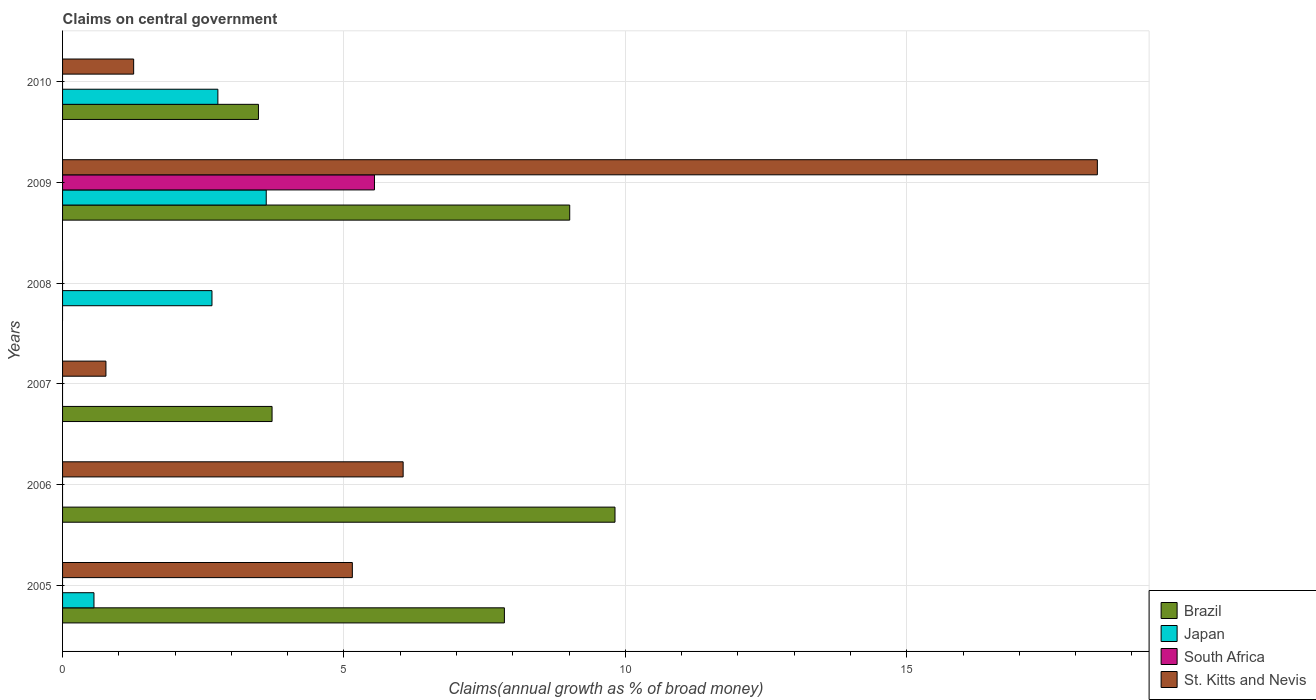How many different coloured bars are there?
Provide a short and direct response. 4. Are the number of bars on each tick of the Y-axis equal?
Your answer should be compact. No. What is the label of the 3rd group of bars from the top?
Make the answer very short. 2008. In how many cases, is the number of bars for a given year not equal to the number of legend labels?
Keep it short and to the point. 5. What is the percentage of broad money claimed on centeral government in Brazil in 2010?
Give a very brief answer. 3.48. Across all years, what is the maximum percentage of broad money claimed on centeral government in St. Kitts and Nevis?
Your response must be concise. 18.39. What is the total percentage of broad money claimed on centeral government in Japan in the graph?
Provide a short and direct response. 9.59. What is the difference between the percentage of broad money claimed on centeral government in St. Kitts and Nevis in 2006 and that in 2010?
Make the answer very short. 4.79. What is the difference between the percentage of broad money claimed on centeral government in St. Kitts and Nevis in 2006 and the percentage of broad money claimed on centeral government in Japan in 2008?
Your answer should be very brief. 3.4. What is the average percentage of broad money claimed on centeral government in South Africa per year?
Your answer should be compact. 0.92. In the year 2006, what is the difference between the percentage of broad money claimed on centeral government in St. Kitts and Nevis and percentage of broad money claimed on centeral government in Brazil?
Provide a short and direct response. -3.76. Is the percentage of broad money claimed on centeral government in St. Kitts and Nevis in 2007 less than that in 2009?
Make the answer very short. Yes. Is the difference between the percentage of broad money claimed on centeral government in St. Kitts and Nevis in 2005 and 2010 greater than the difference between the percentage of broad money claimed on centeral government in Brazil in 2005 and 2010?
Your answer should be compact. No. What is the difference between the highest and the second highest percentage of broad money claimed on centeral government in St. Kitts and Nevis?
Make the answer very short. 12.33. What is the difference between the highest and the lowest percentage of broad money claimed on centeral government in St. Kitts and Nevis?
Provide a succinct answer. 18.39. Is it the case that in every year, the sum of the percentage of broad money claimed on centeral government in Japan and percentage of broad money claimed on centeral government in St. Kitts and Nevis is greater than the percentage of broad money claimed on centeral government in Brazil?
Make the answer very short. No. How many bars are there?
Your answer should be compact. 15. How many years are there in the graph?
Your response must be concise. 6. What is the difference between two consecutive major ticks on the X-axis?
Provide a succinct answer. 5. Are the values on the major ticks of X-axis written in scientific E-notation?
Give a very brief answer. No. Does the graph contain any zero values?
Ensure brevity in your answer.  Yes. Where does the legend appear in the graph?
Provide a succinct answer. Bottom right. How many legend labels are there?
Provide a short and direct response. 4. How are the legend labels stacked?
Your answer should be compact. Vertical. What is the title of the graph?
Your answer should be very brief. Claims on central government. What is the label or title of the X-axis?
Make the answer very short. Claims(annual growth as % of broad money). What is the label or title of the Y-axis?
Offer a very short reply. Years. What is the Claims(annual growth as % of broad money) in Brazil in 2005?
Make the answer very short. 7.85. What is the Claims(annual growth as % of broad money) in Japan in 2005?
Your answer should be very brief. 0.56. What is the Claims(annual growth as % of broad money) of St. Kitts and Nevis in 2005?
Provide a short and direct response. 5.15. What is the Claims(annual growth as % of broad money) in Brazil in 2006?
Your answer should be compact. 9.82. What is the Claims(annual growth as % of broad money) of South Africa in 2006?
Offer a terse response. 0. What is the Claims(annual growth as % of broad money) of St. Kitts and Nevis in 2006?
Give a very brief answer. 6.05. What is the Claims(annual growth as % of broad money) of Brazil in 2007?
Make the answer very short. 3.72. What is the Claims(annual growth as % of broad money) of Japan in 2007?
Keep it short and to the point. 0. What is the Claims(annual growth as % of broad money) of St. Kitts and Nevis in 2007?
Your answer should be compact. 0.77. What is the Claims(annual growth as % of broad money) in Japan in 2008?
Your response must be concise. 2.65. What is the Claims(annual growth as % of broad money) in South Africa in 2008?
Your response must be concise. 0. What is the Claims(annual growth as % of broad money) of St. Kitts and Nevis in 2008?
Make the answer very short. 0. What is the Claims(annual growth as % of broad money) of Brazil in 2009?
Provide a short and direct response. 9.01. What is the Claims(annual growth as % of broad money) in Japan in 2009?
Your answer should be compact. 3.62. What is the Claims(annual growth as % of broad money) in South Africa in 2009?
Your response must be concise. 5.54. What is the Claims(annual growth as % of broad money) of St. Kitts and Nevis in 2009?
Your response must be concise. 18.39. What is the Claims(annual growth as % of broad money) in Brazil in 2010?
Provide a succinct answer. 3.48. What is the Claims(annual growth as % of broad money) of Japan in 2010?
Your response must be concise. 2.76. What is the Claims(annual growth as % of broad money) in South Africa in 2010?
Provide a succinct answer. 0. What is the Claims(annual growth as % of broad money) of St. Kitts and Nevis in 2010?
Ensure brevity in your answer.  1.26. Across all years, what is the maximum Claims(annual growth as % of broad money) in Brazil?
Offer a very short reply. 9.82. Across all years, what is the maximum Claims(annual growth as % of broad money) in Japan?
Your answer should be compact. 3.62. Across all years, what is the maximum Claims(annual growth as % of broad money) of South Africa?
Offer a very short reply. 5.54. Across all years, what is the maximum Claims(annual growth as % of broad money) in St. Kitts and Nevis?
Keep it short and to the point. 18.39. Across all years, what is the minimum Claims(annual growth as % of broad money) in Japan?
Your answer should be very brief. 0. Across all years, what is the minimum Claims(annual growth as % of broad money) in St. Kitts and Nevis?
Your answer should be very brief. 0. What is the total Claims(annual growth as % of broad money) in Brazil in the graph?
Your answer should be very brief. 33.88. What is the total Claims(annual growth as % of broad money) of Japan in the graph?
Ensure brevity in your answer.  9.59. What is the total Claims(annual growth as % of broad money) in South Africa in the graph?
Keep it short and to the point. 5.54. What is the total Claims(annual growth as % of broad money) of St. Kitts and Nevis in the graph?
Give a very brief answer. 31.62. What is the difference between the Claims(annual growth as % of broad money) of Brazil in 2005 and that in 2006?
Offer a very short reply. -1.97. What is the difference between the Claims(annual growth as % of broad money) of St. Kitts and Nevis in 2005 and that in 2006?
Ensure brevity in your answer.  -0.9. What is the difference between the Claims(annual growth as % of broad money) in Brazil in 2005 and that in 2007?
Your answer should be very brief. 4.13. What is the difference between the Claims(annual growth as % of broad money) of St. Kitts and Nevis in 2005 and that in 2007?
Give a very brief answer. 4.38. What is the difference between the Claims(annual growth as % of broad money) of Japan in 2005 and that in 2008?
Give a very brief answer. -2.1. What is the difference between the Claims(annual growth as % of broad money) of Brazil in 2005 and that in 2009?
Provide a short and direct response. -1.16. What is the difference between the Claims(annual growth as % of broad money) in Japan in 2005 and that in 2009?
Your answer should be compact. -3.06. What is the difference between the Claims(annual growth as % of broad money) in St. Kitts and Nevis in 2005 and that in 2009?
Offer a terse response. -13.24. What is the difference between the Claims(annual growth as % of broad money) in Brazil in 2005 and that in 2010?
Provide a short and direct response. 4.37. What is the difference between the Claims(annual growth as % of broad money) in Japan in 2005 and that in 2010?
Keep it short and to the point. -2.2. What is the difference between the Claims(annual growth as % of broad money) in St. Kitts and Nevis in 2005 and that in 2010?
Give a very brief answer. 3.89. What is the difference between the Claims(annual growth as % of broad money) of Brazil in 2006 and that in 2007?
Your answer should be very brief. 6.09. What is the difference between the Claims(annual growth as % of broad money) in St. Kitts and Nevis in 2006 and that in 2007?
Your response must be concise. 5.28. What is the difference between the Claims(annual growth as % of broad money) of Brazil in 2006 and that in 2009?
Keep it short and to the point. 0.8. What is the difference between the Claims(annual growth as % of broad money) of St. Kitts and Nevis in 2006 and that in 2009?
Make the answer very short. -12.33. What is the difference between the Claims(annual growth as % of broad money) of Brazil in 2006 and that in 2010?
Provide a succinct answer. 6.33. What is the difference between the Claims(annual growth as % of broad money) in St. Kitts and Nevis in 2006 and that in 2010?
Offer a terse response. 4.79. What is the difference between the Claims(annual growth as % of broad money) of Brazil in 2007 and that in 2009?
Your answer should be compact. -5.29. What is the difference between the Claims(annual growth as % of broad money) of St. Kitts and Nevis in 2007 and that in 2009?
Provide a succinct answer. -17.61. What is the difference between the Claims(annual growth as % of broad money) in Brazil in 2007 and that in 2010?
Ensure brevity in your answer.  0.24. What is the difference between the Claims(annual growth as % of broad money) of St. Kitts and Nevis in 2007 and that in 2010?
Your response must be concise. -0.49. What is the difference between the Claims(annual growth as % of broad money) in Japan in 2008 and that in 2009?
Keep it short and to the point. -0.96. What is the difference between the Claims(annual growth as % of broad money) in Japan in 2008 and that in 2010?
Your response must be concise. -0.1. What is the difference between the Claims(annual growth as % of broad money) of Brazil in 2009 and that in 2010?
Your answer should be compact. 5.53. What is the difference between the Claims(annual growth as % of broad money) in Japan in 2009 and that in 2010?
Your answer should be very brief. 0.86. What is the difference between the Claims(annual growth as % of broad money) in St. Kitts and Nevis in 2009 and that in 2010?
Provide a short and direct response. 17.12. What is the difference between the Claims(annual growth as % of broad money) in Brazil in 2005 and the Claims(annual growth as % of broad money) in St. Kitts and Nevis in 2006?
Give a very brief answer. 1.8. What is the difference between the Claims(annual growth as % of broad money) of Japan in 2005 and the Claims(annual growth as % of broad money) of St. Kitts and Nevis in 2006?
Offer a very short reply. -5.49. What is the difference between the Claims(annual growth as % of broad money) in Brazil in 2005 and the Claims(annual growth as % of broad money) in St. Kitts and Nevis in 2007?
Ensure brevity in your answer.  7.08. What is the difference between the Claims(annual growth as % of broad money) in Japan in 2005 and the Claims(annual growth as % of broad money) in St. Kitts and Nevis in 2007?
Offer a terse response. -0.21. What is the difference between the Claims(annual growth as % of broad money) in Brazil in 2005 and the Claims(annual growth as % of broad money) in Japan in 2008?
Your response must be concise. 5.2. What is the difference between the Claims(annual growth as % of broad money) in Brazil in 2005 and the Claims(annual growth as % of broad money) in Japan in 2009?
Provide a succinct answer. 4.23. What is the difference between the Claims(annual growth as % of broad money) in Brazil in 2005 and the Claims(annual growth as % of broad money) in South Africa in 2009?
Give a very brief answer. 2.31. What is the difference between the Claims(annual growth as % of broad money) of Brazil in 2005 and the Claims(annual growth as % of broad money) of St. Kitts and Nevis in 2009?
Your response must be concise. -10.54. What is the difference between the Claims(annual growth as % of broad money) of Japan in 2005 and the Claims(annual growth as % of broad money) of South Africa in 2009?
Offer a very short reply. -4.98. What is the difference between the Claims(annual growth as % of broad money) of Japan in 2005 and the Claims(annual growth as % of broad money) of St. Kitts and Nevis in 2009?
Provide a short and direct response. -17.83. What is the difference between the Claims(annual growth as % of broad money) in Brazil in 2005 and the Claims(annual growth as % of broad money) in Japan in 2010?
Provide a succinct answer. 5.09. What is the difference between the Claims(annual growth as % of broad money) in Brazil in 2005 and the Claims(annual growth as % of broad money) in St. Kitts and Nevis in 2010?
Your answer should be compact. 6.59. What is the difference between the Claims(annual growth as % of broad money) of Japan in 2005 and the Claims(annual growth as % of broad money) of St. Kitts and Nevis in 2010?
Offer a terse response. -0.71. What is the difference between the Claims(annual growth as % of broad money) of Brazil in 2006 and the Claims(annual growth as % of broad money) of St. Kitts and Nevis in 2007?
Keep it short and to the point. 9.04. What is the difference between the Claims(annual growth as % of broad money) of Brazil in 2006 and the Claims(annual growth as % of broad money) of Japan in 2008?
Your answer should be very brief. 7.16. What is the difference between the Claims(annual growth as % of broad money) in Brazil in 2006 and the Claims(annual growth as % of broad money) in Japan in 2009?
Your response must be concise. 6.2. What is the difference between the Claims(annual growth as % of broad money) of Brazil in 2006 and the Claims(annual growth as % of broad money) of South Africa in 2009?
Your answer should be very brief. 4.27. What is the difference between the Claims(annual growth as % of broad money) in Brazil in 2006 and the Claims(annual growth as % of broad money) in St. Kitts and Nevis in 2009?
Give a very brief answer. -8.57. What is the difference between the Claims(annual growth as % of broad money) of Brazil in 2006 and the Claims(annual growth as % of broad money) of Japan in 2010?
Your answer should be compact. 7.06. What is the difference between the Claims(annual growth as % of broad money) of Brazil in 2006 and the Claims(annual growth as % of broad money) of St. Kitts and Nevis in 2010?
Ensure brevity in your answer.  8.55. What is the difference between the Claims(annual growth as % of broad money) in Brazil in 2007 and the Claims(annual growth as % of broad money) in Japan in 2008?
Provide a short and direct response. 1.07. What is the difference between the Claims(annual growth as % of broad money) in Brazil in 2007 and the Claims(annual growth as % of broad money) in Japan in 2009?
Keep it short and to the point. 0.1. What is the difference between the Claims(annual growth as % of broad money) of Brazil in 2007 and the Claims(annual growth as % of broad money) of South Africa in 2009?
Your answer should be very brief. -1.82. What is the difference between the Claims(annual growth as % of broad money) in Brazil in 2007 and the Claims(annual growth as % of broad money) in St. Kitts and Nevis in 2009?
Give a very brief answer. -14.66. What is the difference between the Claims(annual growth as % of broad money) of Brazil in 2007 and the Claims(annual growth as % of broad money) of Japan in 2010?
Provide a succinct answer. 0.96. What is the difference between the Claims(annual growth as % of broad money) of Brazil in 2007 and the Claims(annual growth as % of broad money) of St. Kitts and Nevis in 2010?
Provide a short and direct response. 2.46. What is the difference between the Claims(annual growth as % of broad money) of Japan in 2008 and the Claims(annual growth as % of broad money) of South Africa in 2009?
Provide a succinct answer. -2.89. What is the difference between the Claims(annual growth as % of broad money) of Japan in 2008 and the Claims(annual growth as % of broad money) of St. Kitts and Nevis in 2009?
Your answer should be very brief. -15.73. What is the difference between the Claims(annual growth as % of broad money) of Japan in 2008 and the Claims(annual growth as % of broad money) of St. Kitts and Nevis in 2010?
Give a very brief answer. 1.39. What is the difference between the Claims(annual growth as % of broad money) of Brazil in 2009 and the Claims(annual growth as % of broad money) of Japan in 2010?
Your answer should be compact. 6.25. What is the difference between the Claims(annual growth as % of broad money) in Brazil in 2009 and the Claims(annual growth as % of broad money) in St. Kitts and Nevis in 2010?
Ensure brevity in your answer.  7.75. What is the difference between the Claims(annual growth as % of broad money) of Japan in 2009 and the Claims(annual growth as % of broad money) of St. Kitts and Nevis in 2010?
Your answer should be compact. 2.36. What is the difference between the Claims(annual growth as % of broad money) of South Africa in 2009 and the Claims(annual growth as % of broad money) of St. Kitts and Nevis in 2010?
Provide a succinct answer. 4.28. What is the average Claims(annual growth as % of broad money) of Brazil per year?
Provide a short and direct response. 5.65. What is the average Claims(annual growth as % of broad money) in Japan per year?
Your response must be concise. 1.6. What is the average Claims(annual growth as % of broad money) in South Africa per year?
Ensure brevity in your answer.  0.92. What is the average Claims(annual growth as % of broad money) in St. Kitts and Nevis per year?
Ensure brevity in your answer.  5.27. In the year 2005, what is the difference between the Claims(annual growth as % of broad money) in Brazil and Claims(annual growth as % of broad money) in Japan?
Your response must be concise. 7.29. In the year 2005, what is the difference between the Claims(annual growth as % of broad money) in Brazil and Claims(annual growth as % of broad money) in St. Kitts and Nevis?
Ensure brevity in your answer.  2.7. In the year 2005, what is the difference between the Claims(annual growth as % of broad money) of Japan and Claims(annual growth as % of broad money) of St. Kitts and Nevis?
Keep it short and to the point. -4.59. In the year 2006, what is the difference between the Claims(annual growth as % of broad money) in Brazil and Claims(annual growth as % of broad money) in St. Kitts and Nevis?
Offer a very short reply. 3.76. In the year 2007, what is the difference between the Claims(annual growth as % of broad money) in Brazil and Claims(annual growth as % of broad money) in St. Kitts and Nevis?
Make the answer very short. 2.95. In the year 2009, what is the difference between the Claims(annual growth as % of broad money) of Brazil and Claims(annual growth as % of broad money) of Japan?
Provide a succinct answer. 5.39. In the year 2009, what is the difference between the Claims(annual growth as % of broad money) of Brazil and Claims(annual growth as % of broad money) of South Africa?
Your answer should be very brief. 3.47. In the year 2009, what is the difference between the Claims(annual growth as % of broad money) in Brazil and Claims(annual growth as % of broad money) in St. Kitts and Nevis?
Provide a short and direct response. -9.37. In the year 2009, what is the difference between the Claims(annual growth as % of broad money) in Japan and Claims(annual growth as % of broad money) in South Africa?
Provide a short and direct response. -1.92. In the year 2009, what is the difference between the Claims(annual growth as % of broad money) in Japan and Claims(annual growth as % of broad money) in St. Kitts and Nevis?
Make the answer very short. -14.77. In the year 2009, what is the difference between the Claims(annual growth as % of broad money) of South Africa and Claims(annual growth as % of broad money) of St. Kitts and Nevis?
Provide a short and direct response. -12.84. In the year 2010, what is the difference between the Claims(annual growth as % of broad money) of Brazil and Claims(annual growth as % of broad money) of Japan?
Your response must be concise. 0.72. In the year 2010, what is the difference between the Claims(annual growth as % of broad money) of Brazil and Claims(annual growth as % of broad money) of St. Kitts and Nevis?
Keep it short and to the point. 2.22. In the year 2010, what is the difference between the Claims(annual growth as % of broad money) in Japan and Claims(annual growth as % of broad money) in St. Kitts and Nevis?
Provide a succinct answer. 1.5. What is the ratio of the Claims(annual growth as % of broad money) of Brazil in 2005 to that in 2006?
Ensure brevity in your answer.  0.8. What is the ratio of the Claims(annual growth as % of broad money) in St. Kitts and Nevis in 2005 to that in 2006?
Keep it short and to the point. 0.85. What is the ratio of the Claims(annual growth as % of broad money) in Brazil in 2005 to that in 2007?
Provide a short and direct response. 2.11. What is the ratio of the Claims(annual growth as % of broad money) of St. Kitts and Nevis in 2005 to that in 2007?
Your response must be concise. 6.68. What is the ratio of the Claims(annual growth as % of broad money) in Japan in 2005 to that in 2008?
Make the answer very short. 0.21. What is the ratio of the Claims(annual growth as % of broad money) in Brazil in 2005 to that in 2009?
Give a very brief answer. 0.87. What is the ratio of the Claims(annual growth as % of broad money) in Japan in 2005 to that in 2009?
Make the answer very short. 0.15. What is the ratio of the Claims(annual growth as % of broad money) of St. Kitts and Nevis in 2005 to that in 2009?
Your answer should be very brief. 0.28. What is the ratio of the Claims(annual growth as % of broad money) of Brazil in 2005 to that in 2010?
Your answer should be compact. 2.26. What is the ratio of the Claims(annual growth as % of broad money) of Japan in 2005 to that in 2010?
Make the answer very short. 0.2. What is the ratio of the Claims(annual growth as % of broad money) of St. Kitts and Nevis in 2005 to that in 2010?
Keep it short and to the point. 4.08. What is the ratio of the Claims(annual growth as % of broad money) of Brazil in 2006 to that in 2007?
Make the answer very short. 2.64. What is the ratio of the Claims(annual growth as % of broad money) in St. Kitts and Nevis in 2006 to that in 2007?
Provide a short and direct response. 7.85. What is the ratio of the Claims(annual growth as % of broad money) in Brazil in 2006 to that in 2009?
Your answer should be compact. 1.09. What is the ratio of the Claims(annual growth as % of broad money) of St. Kitts and Nevis in 2006 to that in 2009?
Your answer should be compact. 0.33. What is the ratio of the Claims(annual growth as % of broad money) of Brazil in 2006 to that in 2010?
Your answer should be compact. 2.82. What is the ratio of the Claims(annual growth as % of broad money) in St. Kitts and Nevis in 2006 to that in 2010?
Keep it short and to the point. 4.79. What is the ratio of the Claims(annual growth as % of broad money) of Brazil in 2007 to that in 2009?
Give a very brief answer. 0.41. What is the ratio of the Claims(annual growth as % of broad money) of St. Kitts and Nevis in 2007 to that in 2009?
Your answer should be very brief. 0.04. What is the ratio of the Claims(annual growth as % of broad money) of Brazil in 2007 to that in 2010?
Provide a succinct answer. 1.07. What is the ratio of the Claims(annual growth as % of broad money) of St. Kitts and Nevis in 2007 to that in 2010?
Your answer should be compact. 0.61. What is the ratio of the Claims(annual growth as % of broad money) in Japan in 2008 to that in 2009?
Provide a short and direct response. 0.73. What is the ratio of the Claims(annual growth as % of broad money) in Brazil in 2009 to that in 2010?
Provide a succinct answer. 2.59. What is the ratio of the Claims(annual growth as % of broad money) of Japan in 2009 to that in 2010?
Offer a terse response. 1.31. What is the ratio of the Claims(annual growth as % of broad money) in St. Kitts and Nevis in 2009 to that in 2010?
Your answer should be very brief. 14.56. What is the difference between the highest and the second highest Claims(annual growth as % of broad money) in Brazil?
Your answer should be compact. 0.8. What is the difference between the highest and the second highest Claims(annual growth as % of broad money) of Japan?
Ensure brevity in your answer.  0.86. What is the difference between the highest and the second highest Claims(annual growth as % of broad money) of St. Kitts and Nevis?
Offer a terse response. 12.33. What is the difference between the highest and the lowest Claims(annual growth as % of broad money) of Brazil?
Provide a short and direct response. 9.82. What is the difference between the highest and the lowest Claims(annual growth as % of broad money) in Japan?
Your answer should be compact. 3.62. What is the difference between the highest and the lowest Claims(annual growth as % of broad money) in South Africa?
Offer a very short reply. 5.54. What is the difference between the highest and the lowest Claims(annual growth as % of broad money) of St. Kitts and Nevis?
Give a very brief answer. 18.39. 